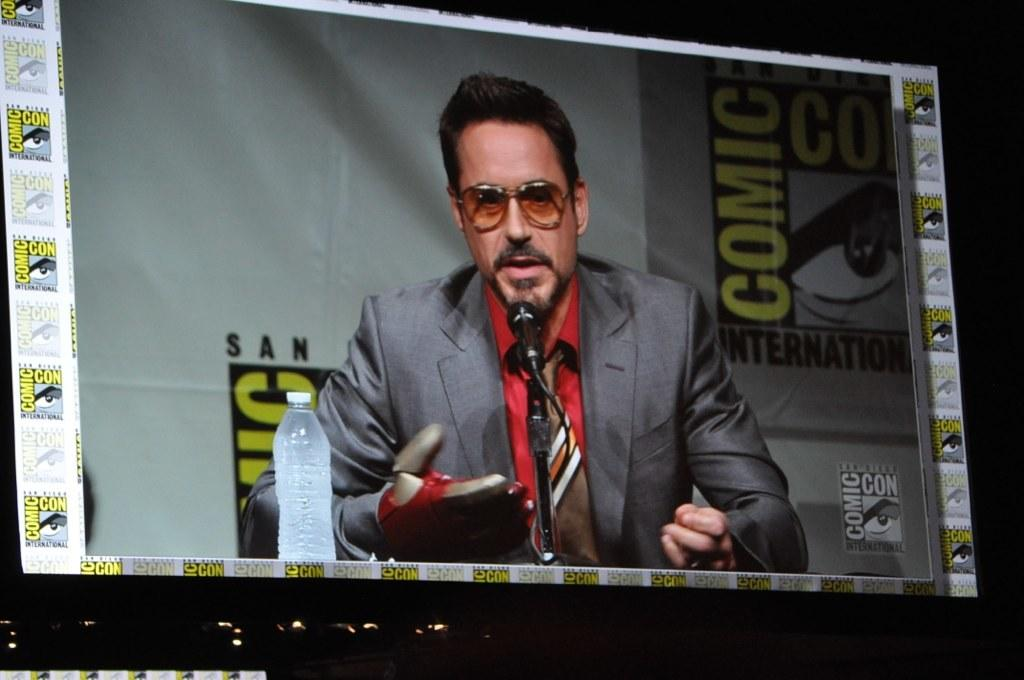What is the man in the image doing? The man is speaking into a microphone. What type of clothing is the man wearing? The man is wearing a tie, a shirt, and a coat. Can you describe the man's accessories in the image? There is a water bottle on the left side of the image. What reward does the man receive for his temper in the image? There is no mention of a reward or temper in the image; the man is simply speaking into a microphone. 